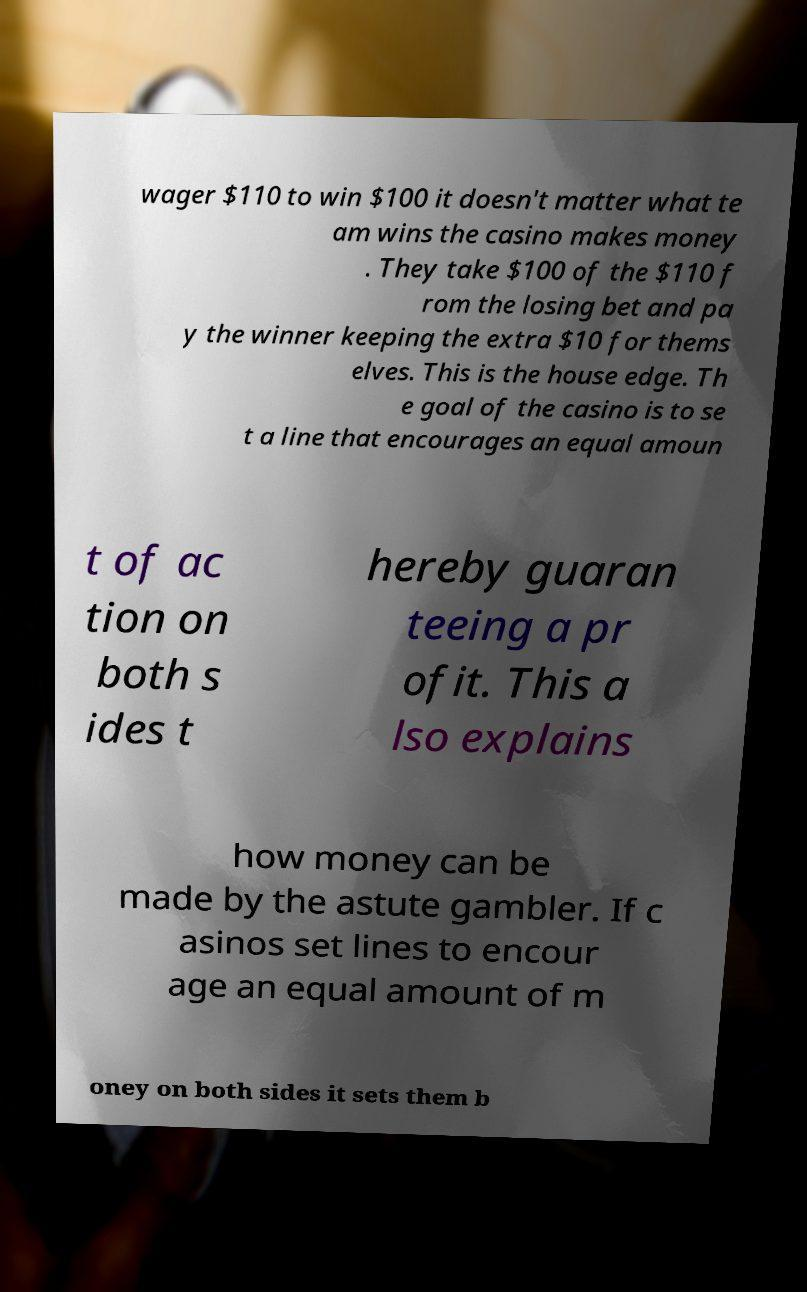Could you extract and type out the text from this image? wager $110 to win $100 it doesn't matter what te am wins the casino makes money . They take $100 of the $110 f rom the losing bet and pa y the winner keeping the extra $10 for thems elves. This is the house edge. Th e goal of the casino is to se t a line that encourages an equal amoun t of ac tion on both s ides t hereby guaran teeing a pr ofit. This a lso explains how money can be made by the astute gambler. If c asinos set lines to encour age an equal amount of m oney on both sides it sets them b 